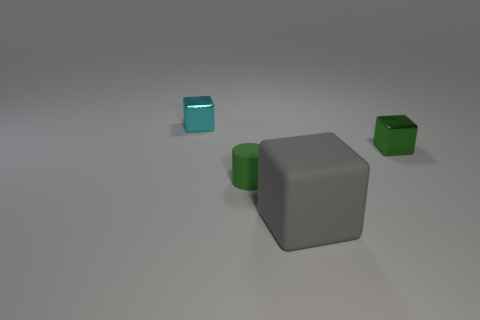Given that the gray cube and the green cylinder share the same material, what might be the purpose of the other, shiny cube? The shiny cube, with its reflective surface and contrasting visual properties, might be present to provide a comparison in texture and material properties. It exemplifies how different surfaces interact with light and adds variety to the composition of objects in the scene. Could it be part of a study on materials and lighting? Absolutely, this setup could indeed be used to study the interplay of materials, textures, and lighting. Such an arrangement allows observers to compare how matte and glossy surfaces reflect or absorb light differently, which is essential for visual arts and design disciplines. 